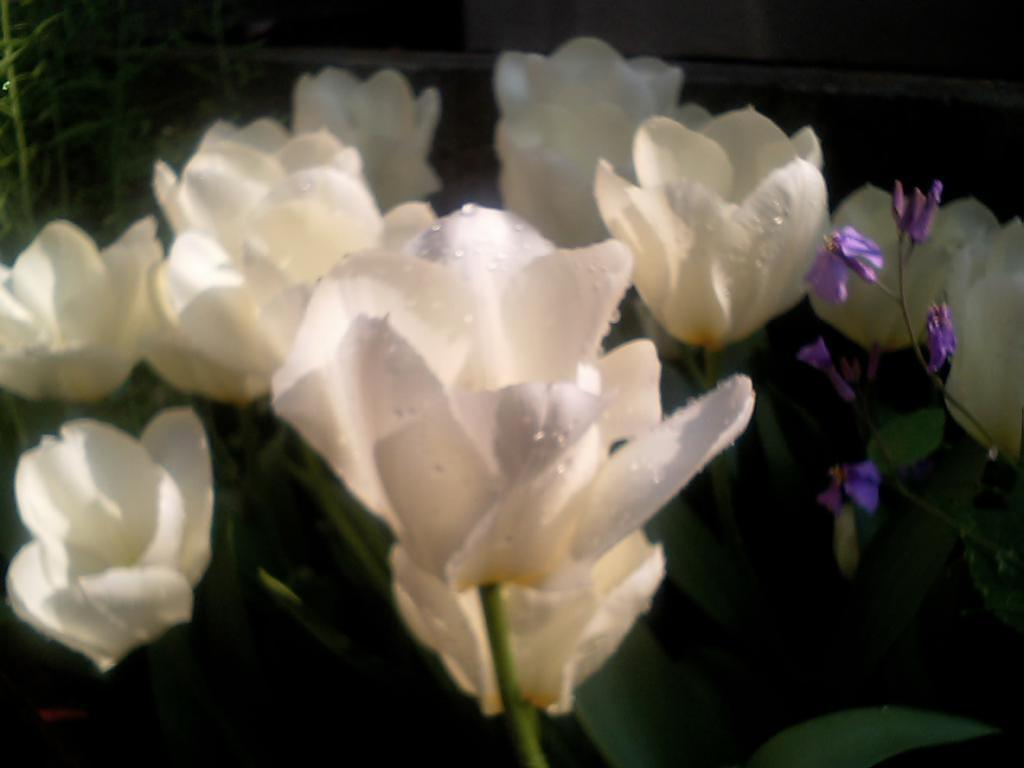What type of plants are in the image? There are plants with white and purple flowers in the image. What can be seen in the background of the image? There is a building and a wall in the background of the image. What type of wool is being used to create the chin in the image? There is no wool or chin present in the image; it features plants with white and purple flowers and a background with a building and a wall. 